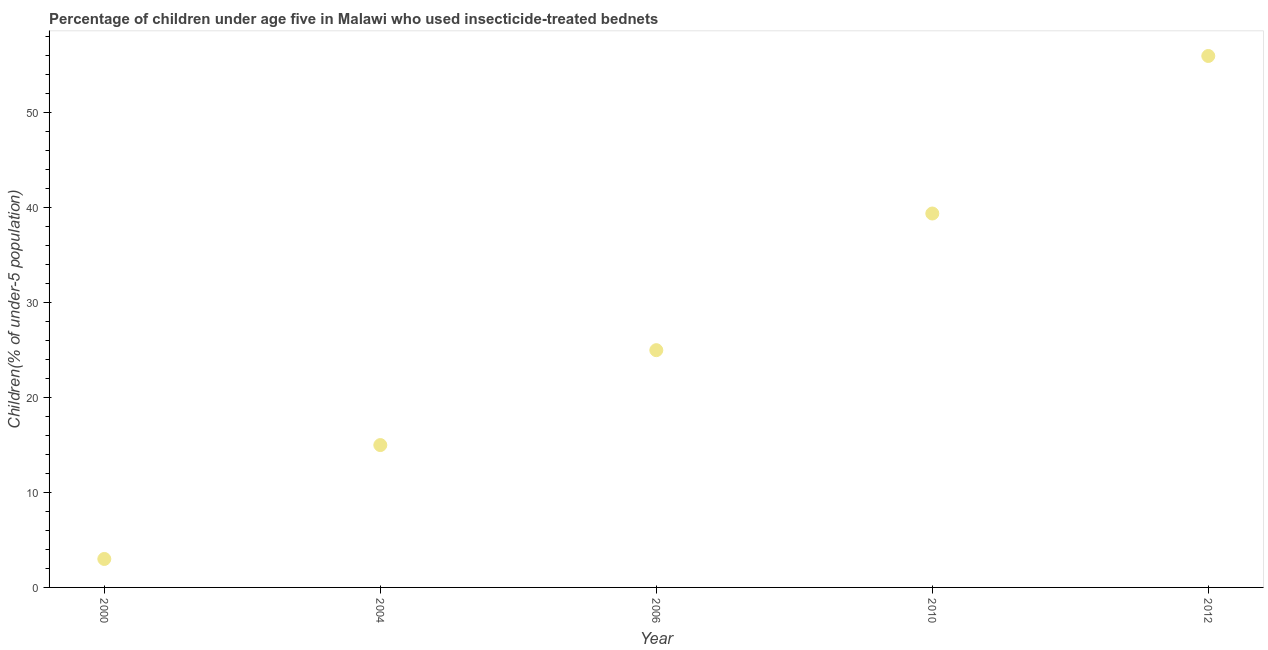What is the percentage of children who use of insecticide-treated bed nets in 2006?
Provide a succinct answer. 25. Across all years, what is the maximum percentage of children who use of insecticide-treated bed nets?
Give a very brief answer. 56. In which year was the percentage of children who use of insecticide-treated bed nets minimum?
Provide a short and direct response. 2000. What is the sum of the percentage of children who use of insecticide-treated bed nets?
Offer a very short reply. 138.4. What is the difference between the percentage of children who use of insecticide-treated bed nets in 2004 and 2012?
Offer a terse response. -41. What is the average percentage of children who use of insecticide-treated bed nets per year?
Your answer should be compact. 27.68. What is the median percentage of children who use of insecticide-treated bed nets?
Your response must be concise. 25. What is the ratio of the percentage of children who use of insecticide-treated bed nets in 2006 to that in 2012?
Give a very brief answer. 0.45. Is the difference between the percentage of children who use of insecticide-treated bed nets in 2006 and 2012 greater than the difference between any two years?
Offer a terse response. No. What is the difference between the highest and the second highest percentage of children who use of insecticide-treated bed nets?
Keep it short and to the point. 16.6. Is the sum of the percentage of children who use of insecticide-treated bed nets in 2010 and 2012 greater than the maximum percentage of children who use of insecticide-treated bed nets across all years?
Offer a very short reply. Yes. What is the difference between the highest and the lowest percentage of children who use of insecticide-treated bed nets?
Make the answer very short. 53. In how many years, is the percentage of children who use of insecticide-treated bed nets greater than the average percentage of children who use of insecticide-treated bed nets taken over all years?
Your answer should be very brief. 2. What is the difference between two consecutive major ticks on the Y-axis?
Give a very brief answer. 10. What is the title of the graph?
Keep it short and to the point. Percentage of children under age five in Malawi who used insecticide-treated bednets. What is the label or title of the X-axis?
Ensure brevity in your answer.  Year. What is the label or title of the Y-axis?
Ensure brevity in your answer.  Children(% of under-5 population). What is the Children(% of under-5 population) in 2000?
Keep it short and to the point. 3. What is the Children(% of under-5 population) in 2004?
Offer a very short reply. 15. What is the Children(% of under-5 population) in 2006?
Offer a terse response. 25. What is the Children(% of under-5 population) in 2010?
Make the answer very short. 39.4. What is the difference between the Children(% of under-5 population) in 2000 and 2010?
Your answer should be very brief. -36.4. What is the difference between the Children(% of under-5 population) in 2000 and 2012?
Ensure brevity in your answer.  -53. What is the difference between the Children(% of under-5 population) in 2004 and 2010?
Provide a short and direct response. -24.4. What is the difference between the Children(% of under-5 population) in 2004 and 2012?
Your answer should be compact. -41. What is the difference between the Children(% of under-5 population) in 2006 and 2010?
Your response must be concise. -14.4. What is the difference between the Children(% of under-5 population) in 2006 and 2012?
Make the answer very short. -31. What is the difference between the Children(% of under-5 population) in 2010 and 2012?
Your answer should be very brief. -16.6. What is the ratio of the Children(% of under-5 population) in 2000 to that in 2006?
Provide a short and direct response. 0.12. What is the ratio of the Children(% of under-5 population) in 2000 to that in 2010?
Your answer should be compact. 0.08. What is the ratio of the Children(% of under-5 population) in 2000 to that in 2012?
Give a very brief answer. 0.05. What is the ratio of the Children(% of under-5 population) in 2004 to that in 2006?
Your answer should be compact. 0.6. What is the ratio of the Children(% of under-5 population) in 2004 to that in 2010?
Ensure brevity in your answer.  0.38. What is the ratio of the Children(% of under-5 population) in 2004 to that in 2012?
Your answer should be compact. 0.27. What is the ratio of the Children(% of under-5 population) in 2006 to that in 2010?
Ensure brevity in your answer.  0.64. What is the ratio of the Children(% of under-5 population) in 2006 to that in 2012?
Ensure brevity in your answer.  0.45. What is the ratio of the Children(% of under-5 population) in 2010 to that in 2012?
Ensure brevity in your answer.  0.7. 